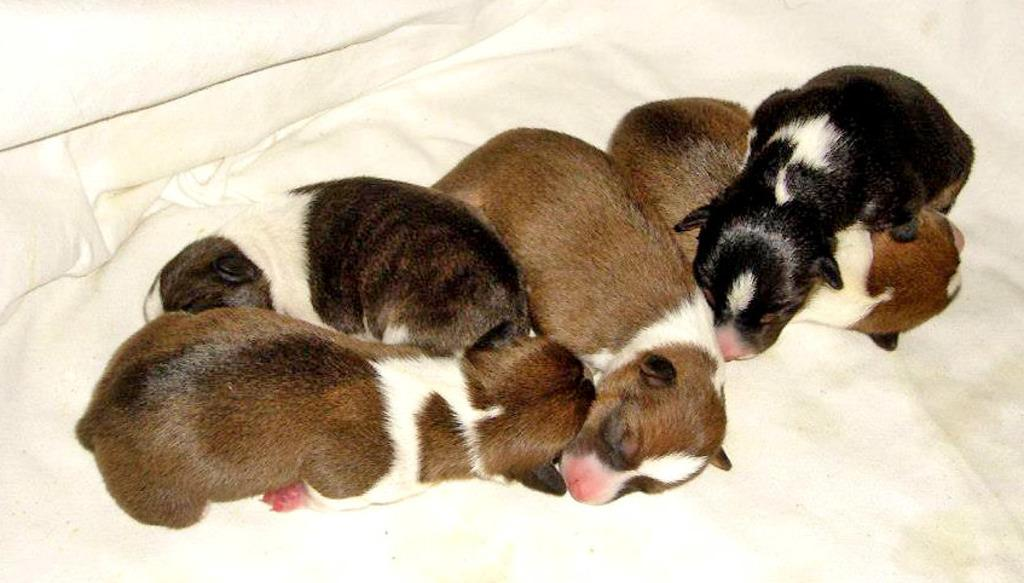What type of animals are present in the image? There are dogs in the image. Can you describe the surface on which the dogs are situated? The dogs are on a white cloth. What type of bear can be seen in the image? There is no bear present in the image; it features dogs on a white cloth. How long does it take for the dogs to walk a minute in the image? The image is a still photograph, so the dogs are not walking, and therefore it is not possible to determine how long it would take them to walk a minute. 